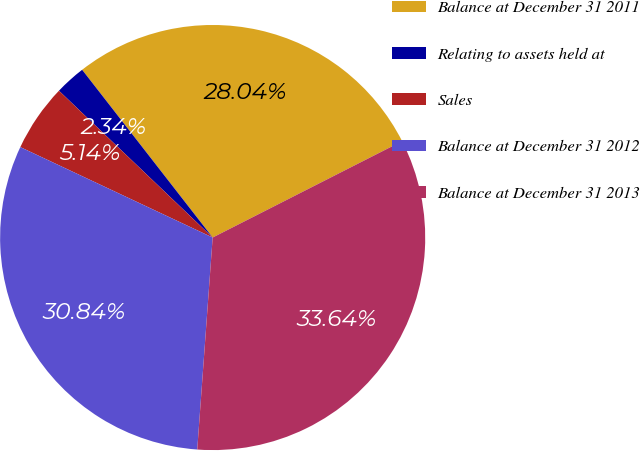Convert chart to OTSL. <chart><loc_0><loc_0><loc_500><loc_500><pie_chart><fcel>Balance at December 31 2011<fcel>Relating to assets held at<fcel>Sales<fcel>Balance at December 31 2012<fcel>Balance at December 31 2013<nl><fcel>28.04%<fcel>2.34%<fcel>5.14%<fcel>30.84%<fcel>33.64%<nl></chart> 